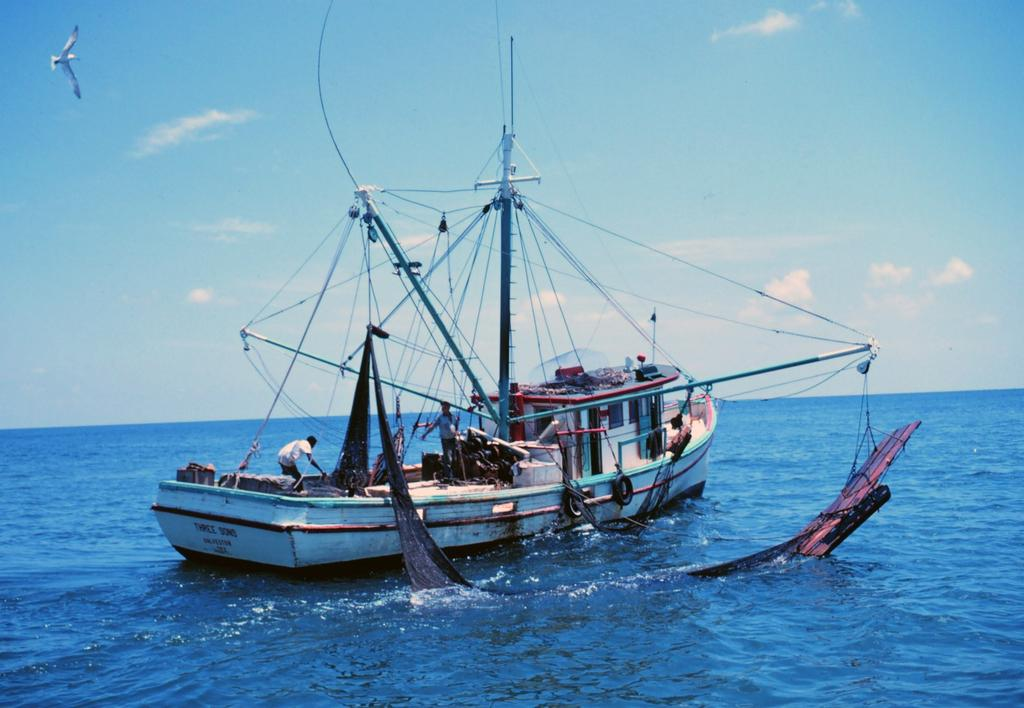What is the main subject of the image? The main subject of the image is a boat. Where is the boat located? The boat is on the water. What can be seen in the water near the boat? There is a fishing net in the water. What is visible in the background of the image? There is a bird flying in the sky in the background of the image. Is the boat stuck in quicksand in the image? No, the boat is not stuck in quicksand; it is on the water. What type of mark can be seen on the bird's wing in the image? There is no mark visible on the bird's wing in the image. 